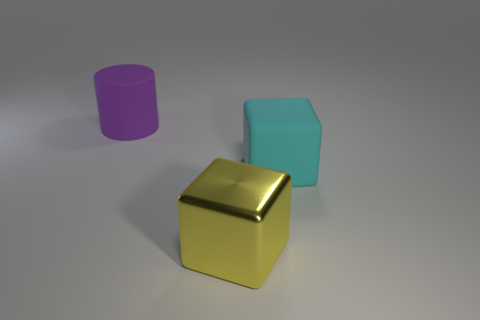How many other things are there of the same material as the purple cylinder? 1 